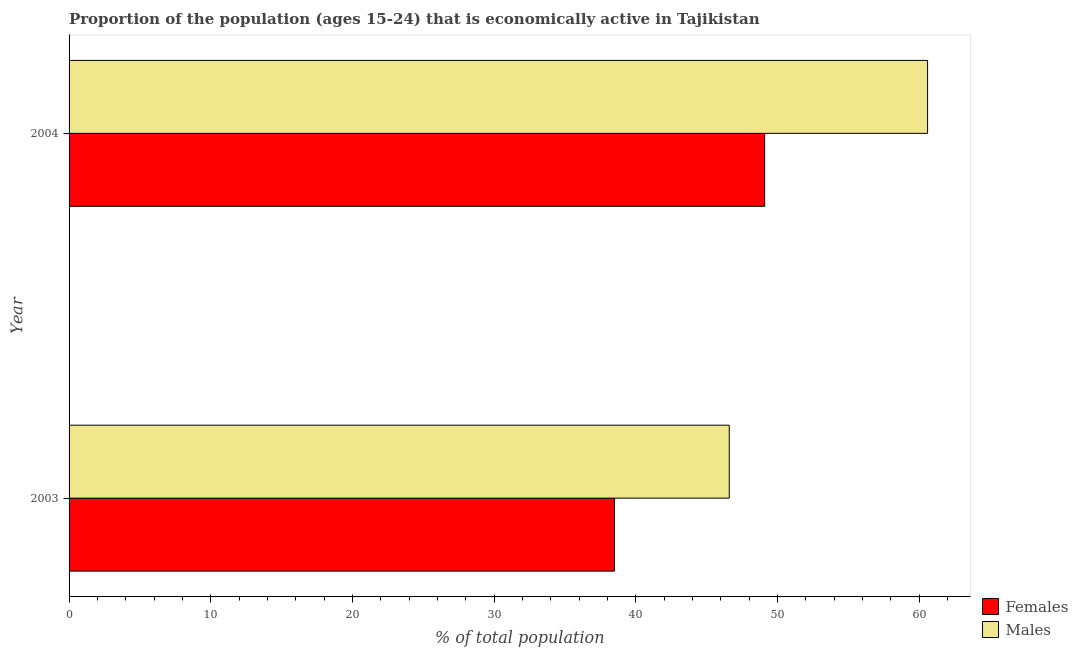How many groups of bars are there?
Ensure brevity in your answer.  2. Are the number of bars per tick equal to the number of legend labels?
Offer a very short reply. Yes. Are the number of bars on each tick of the Y-axis equal?
Provide a short and direct response. Yes. What is the percentage of economically active female population in 2003?
Give a very brief answer. 38.5. Across all years, what is the maximum percentage of economically active male population?
Provide a succinct answer. 60.6. Across all years, what is the minimum percentage of economically active female population?
Keep it short and to the point. 38.5. What is the total percentage of economically active male population in the graph?
Ensure brevity in your answer.  107.2. What is the difference between the percentage of economically active male population in 2003 and that in 2004?
Ensure brevity in your answer.  -14. What is the average percentage of economically active male population per year?
Offer a terse response. 53.6. In the year 2003, what is the difference between the percentage of economically active female population and percentage of economically active male population?
Provide a short and direct response. -8.1. What is the ratio of the percentage of economically active female population in 2003 to that in 2004?
Make the answer very short. 0.78. What does the 2nd bar from the top in 2004 represents?
Keep it short and to the point. Females. What does the 1st bar from the bottom in 2003 represents?
Provide a short and direct response. Females. How many bars are there?
Keep it short and to the point. 4. Are all the bars in the graph horizontal?
Ensure brevity in your answer.  Yes. How many years are there in the graph?
Your answer should be very brief. 2. What is the difference between two consecutive major ticks on the X-axis?
Offer a terse response. 10. Are the values on the major ticks of X-axis written in scientific E-notation?
Provide a short and direct response. No. Does the graph contain any zero values?
Provide a short and direct response. No. Does the graph contain grids?
Keep it short and to the point. No. How are the legend labels stacked?
Provide a short and direct response. Vertical. What is the title of the graph?
Offer a very short reply. Proportion of the population (ages 15-24) that is economically active in Tajikistan. Does "Transport services" appear as one of the legend labels in the graph?
Provide a short and direct response. No. What is the label or title of the X-axis?
Keep it short and to the point. % of total population. What is the label or title of the Y-axis?
Ensure brevity in your answer.  Year. What is the % of total population of Females in 2003?
Your response must be concise. 38.5. What is the % of total population of Males in 2003?
Your answer should be compact. 46.6. What is the % of total population in Females in 2004?
Offer a very short reply. 49.1. What is the % of total population of Males in 2004?
Provide a short and direct response. 60.6. Across all years, what is the maximum % of total population of Females?
Offer a very short reply. 49.1. Across all years, what is the maximum % of total population of Males?
Provide a succinct answer. 60.6. Across all years, what is the minimum % of total population in Females?
Your answer should be compact. 38.5. Across all years, what is the minimum % of total population of Males?
Your answer should be compact. 46.6. What is the total % of total population in Females in the graph?
Your response must be concise. 87.6. What is the total % of total population in Males in the graph?
Offer a very short reply. 107.2. What is the difference between the % of total population of Females in 2003 and the % of total population of Males in 2004?
Offer a very short reply. -22.1. What is the average % of total population in Females per year?
Your response must be concise. 43.8. What is the average % of total population of Males per year?
Provide a short and direct response. 53.6. In the year 2003, what is the difference between the % of total population of Females and % of total population of Males?
Offer a very short reply. -8.1. What is the ratio of the % of total population of Females in 2003 to that in 2004?
Ensure brevity in your answer.  0.78. What is the ratio of the % of total population in Males in 2003 to that in 2004?
Ensure brevity in your answer.  0.77. What is the difference between the highest and the second highest % of total population in Males?
Keep it short and to the point. 14. What is the difference between the highest and the lowest % of total population of Females?
Your answer should be compact. 10.6. 